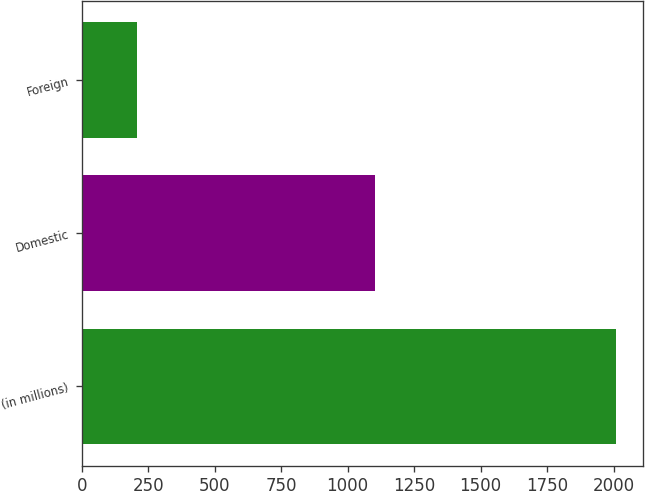Convert chart. <chart><loc_0><loc_0><loc_500><loc_500><bar_chart><fcel>(in millions)<fcel>Domestic<fcel>Foreign<nl><fcel>2009<fcel>1102<fcel>206<nl></chart> 